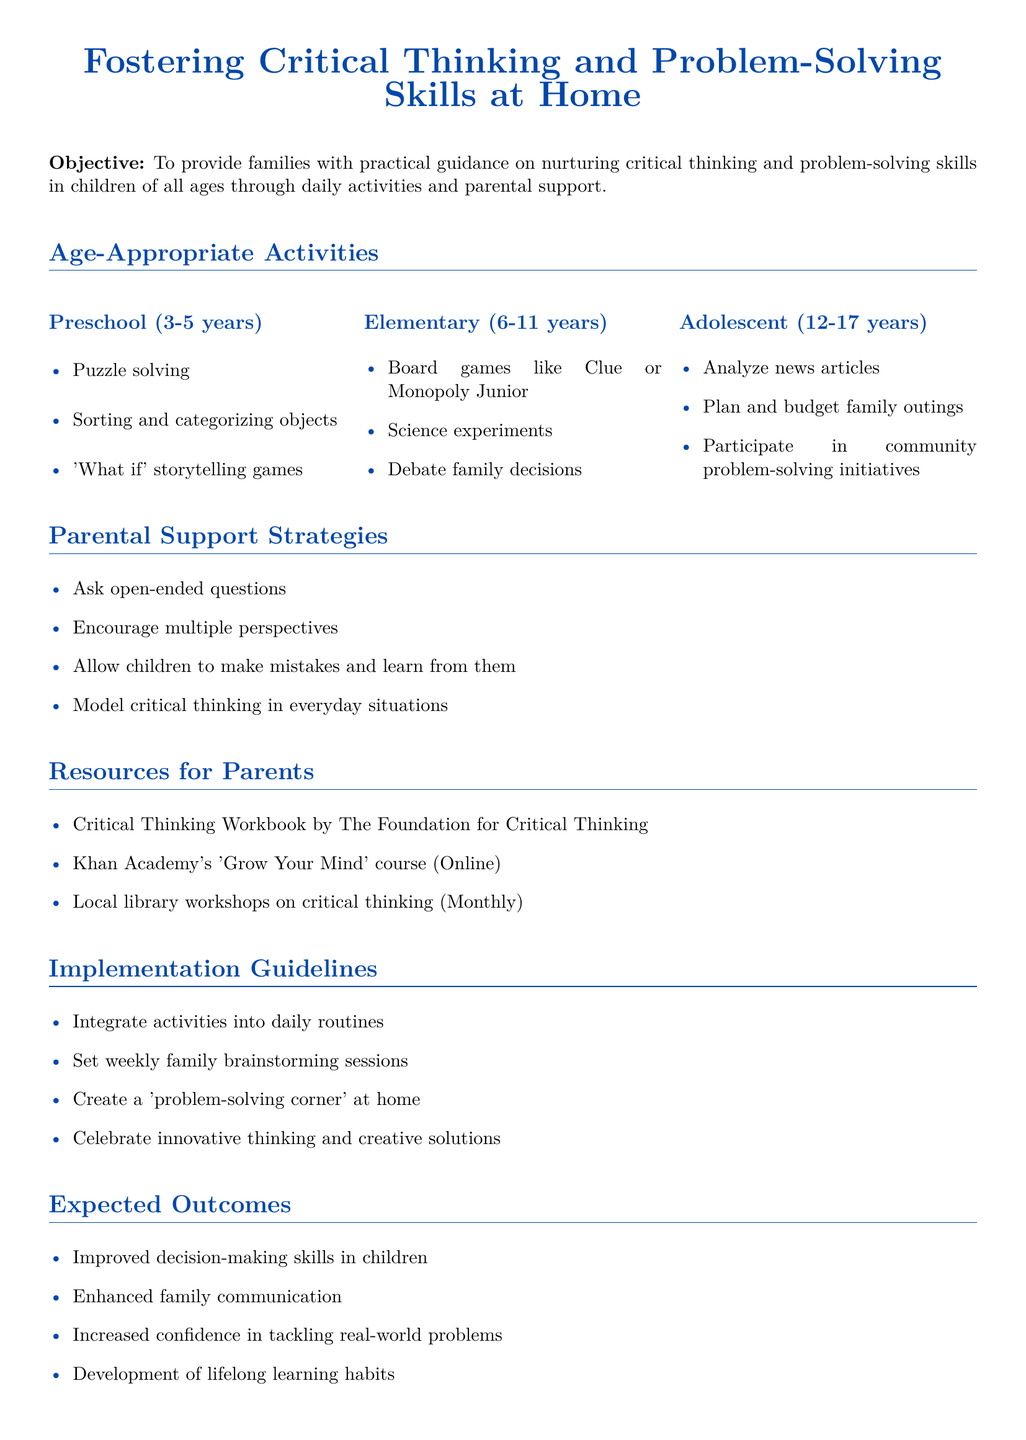What age group is targeted for preschool activities? The document specifies that activities for preschool are designed for children aged 3-5 years.
Answer: 3-5 years What is one of the parental support strategies mentioned? The document outlines several strategies, one of which is to ask open-ended questions.
Answer: Ask open-ended questions Name one resource for parents listed in the document. The document provides several resources, including the Critical Thinking Workbook by The Foundation for Critical Thinking.
Answer: Critical Thinking Workbook by The Foundation for Critical Thinking Which activity is suggested for adolescents aged 12-17? The document suggests analyzing news articles as an activity for this age group.
Answer: Analyze news articles What is one expected outcome of implementing the guidance policy? The document states that one expected outcome is improved decision-making skills in children.
Answer: Improved decision-making skills in children How should families integrate the suggested activities into their lives? The document recommends integrating activities into daily routines.
Answer: Integrate activities into daily routines What is the document's primary objective? The objective outlined in the document is to provide families with practical guidance on nurturing critical thinking and problem-solving skills.
Answer: Practical guidance on nurturing critical thinking and problem-solving skills What type of games are suggested for elementary children? Board games like Clue or Monopoly Junior are recommended for elementary-aged children.
Answer: Board games like Clue or Monopoly Junior 